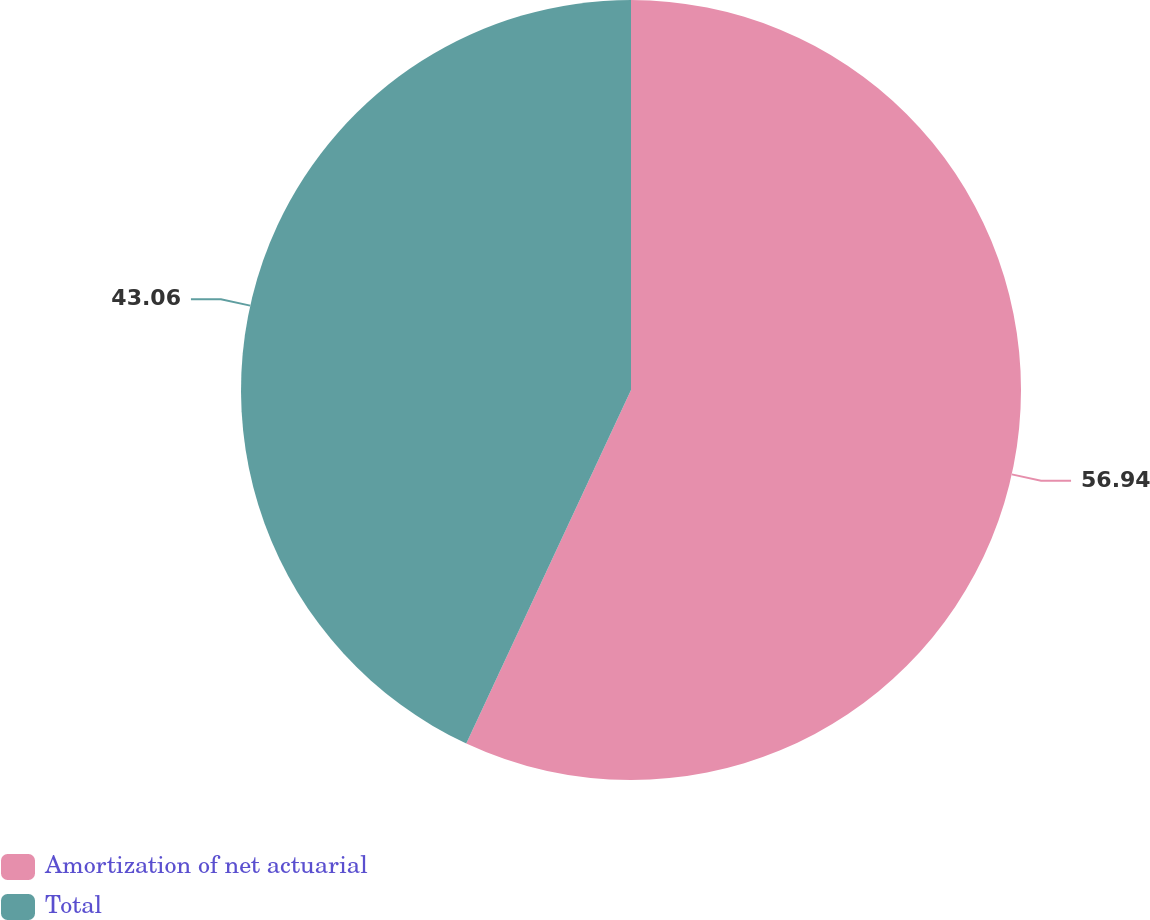Convert chart. <chart><loc_0><loc_0><loc_500><loc_500><pie_chart><fcel>Amortization of net actuarial<fcel>Total<nl><fcel>56.94%<fcel>43.06%<nl></chart> 